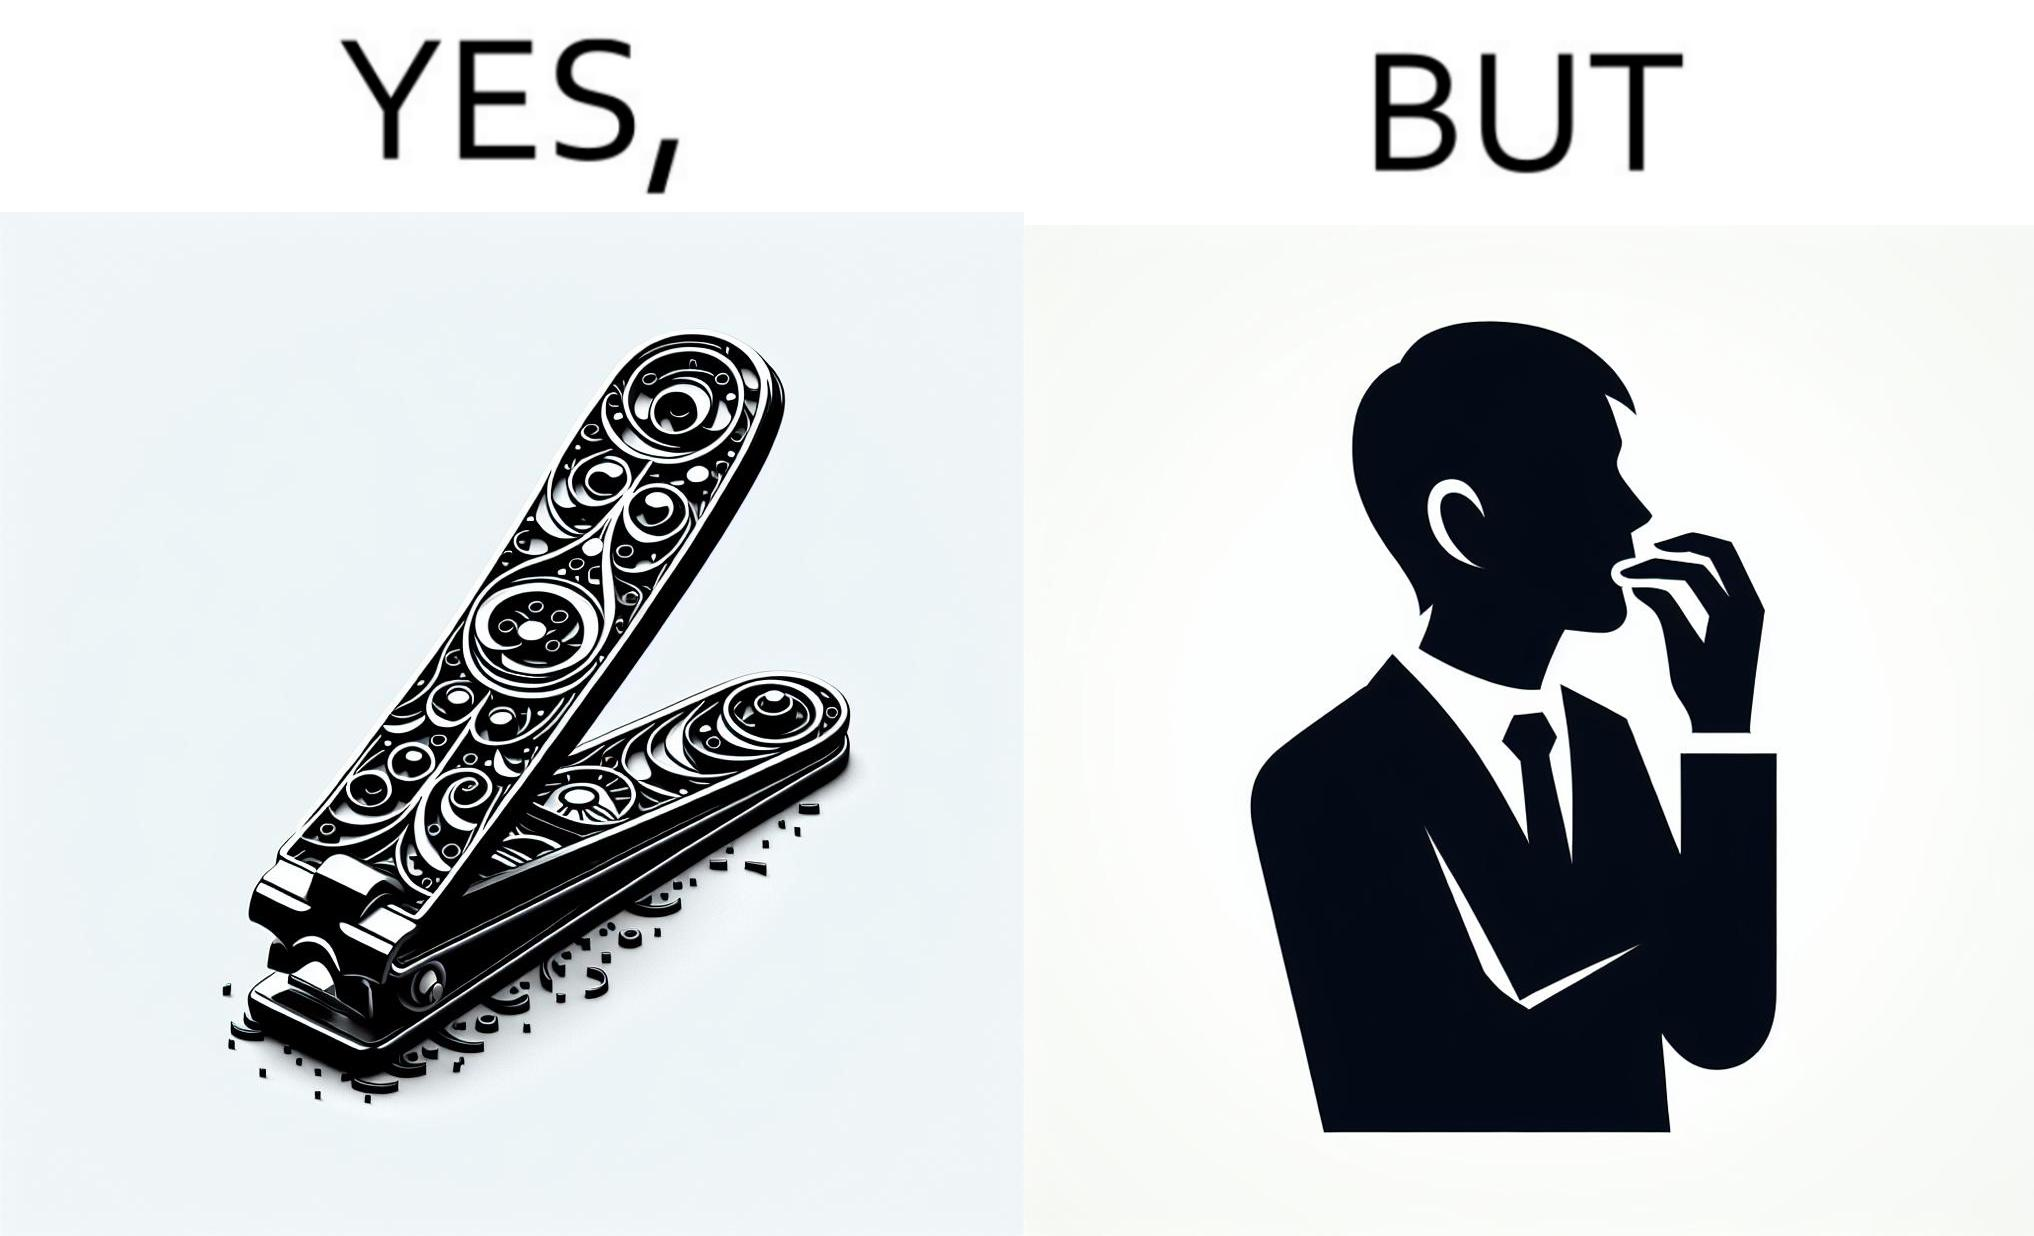Describe the satirical element in this image. The image is ironic, because even after nail clippers are available people prefer biting their nails by teeth 